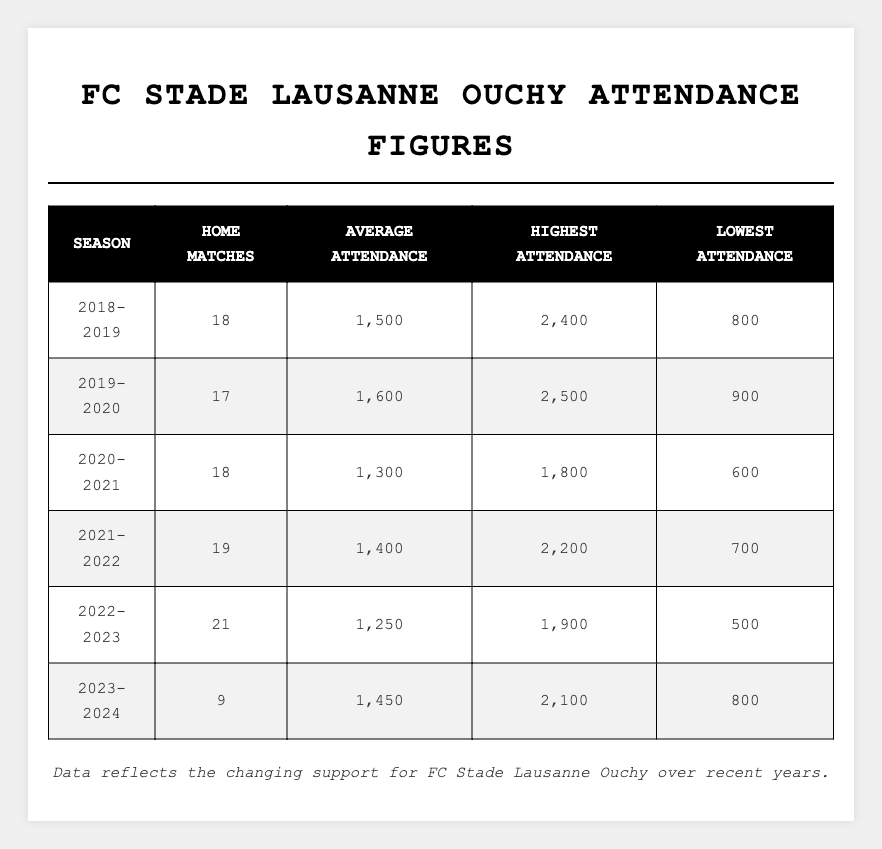What was the highest attendance in the 2019-2020 season? In the 2019-2020 season, the table shows the highest attendance figure was 2500.
Answer: 2500 What is the average attendance for the home matches in 2021-2022? The average attendance for the 2021-2022 season, as listed in the table, is 1400.
Answer: 1400 How many home matches were played in the 2022-2023 season? According to the table, there were 21 home matches played in the 2022-2023 season.
Answer: 21 What is the difference between the highest and lowest attendance in the 2020-2021 season? For the 2020-2021 season, the highest attendance was 1800 and the lowest was 600. The difference is 1800 - 600 = 1200.
Answer: 1200 Was the average attendance in the 2022-2023 season lower than in the 2020-2021 season? The average attendance in 2022-2023 was 1250, while in 2020-2021 it was 1300. Since 1250 is less than 1300, the statement is true.
Answer: Yes Which season had the highest average attendance? By comparing the average attendances from the table, the 2019-2020 season had the highest average attendance at 1600.
Answer: 2019-2020 How does the average attendance in 2023-2024 compare with the 2022-2023 season? The average attendance in 2023-2024 is 1450, while in 2022-2023 it was 1250. Since 1450 is greater than 1250, 2023-2024 has a higher average.
Answer: Higher What was the total attendance over all home matches in the 2018-2019 season? The total attendance is calculated by multiplying the average attendance (1500) by the number of home matches (18), which gives 1500 * 18 = 27000.
Answer: 27000 In which season did the club have the lowest average attendance? The table shows that the lowest average attendance occurred in the 2022-2023 season, with an average of 1250.
Answer: 2022-2023 What was the trend in average attendance from 2018-2019 to 2022-2023? Analyzing the average attendance figures: 2018-2019 (1500), 2019-2020 (1600), 2020-2021 (1300), 2021-2022 (1400), 2022-2023 (1250), shows that there was an increase from 2018-2019 to 2019-2020, then a decline thereafter towards 2022-2023.
Answer: Decreasing trend after 2019-2020 